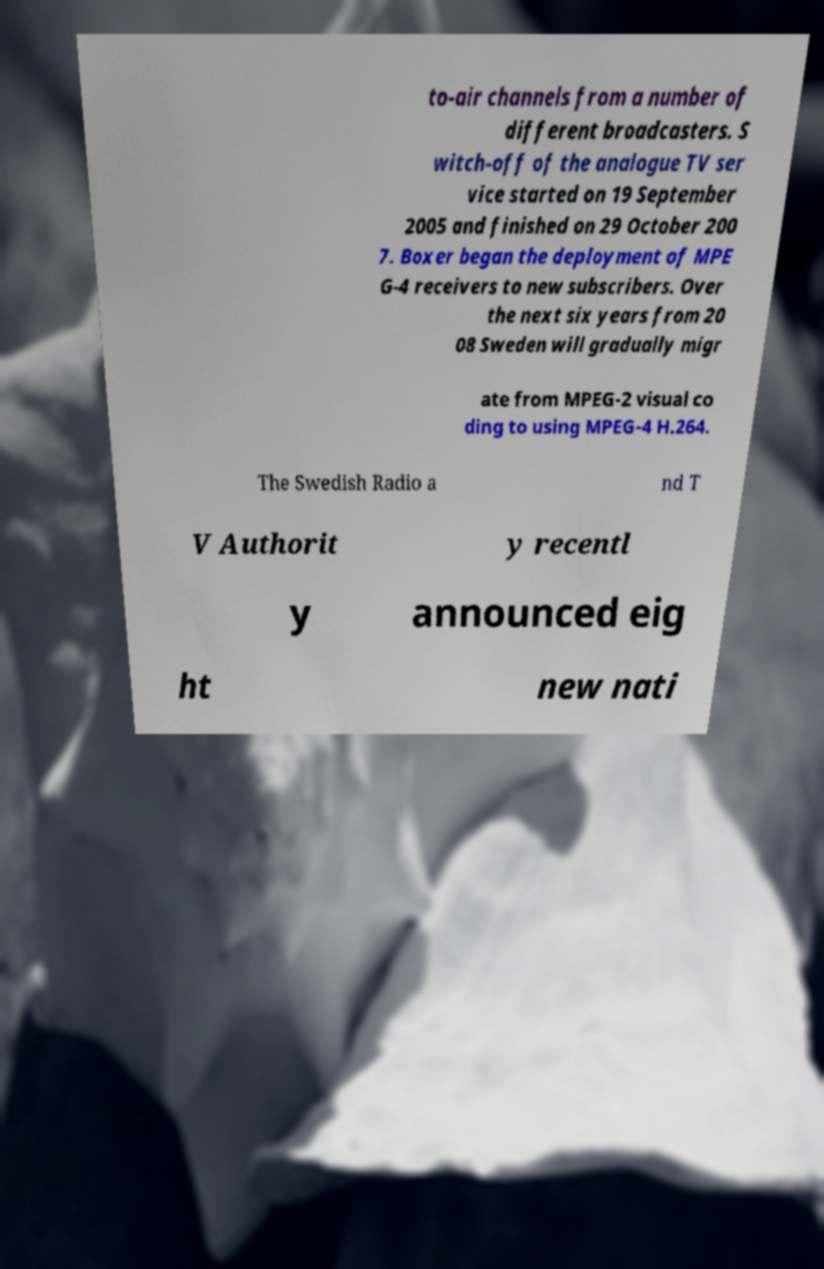Can you accurately transcribe the text from the provided image for me? to-air channels from a number of different broadcasters. S witch-off of the analogue TV ser vice started on 19 September 2005 and finished on 29 October 200 7. Boxer began the deployment of MPE G-4 receivers to new subscribers. Over the next six years from 20 08 Sweden will gradually migr ate from MPEG-2 visual co ding to using MPEG-4 H.264. The Swedish Radio a nd T V Authorit y recentl y announced eig ht new nati 